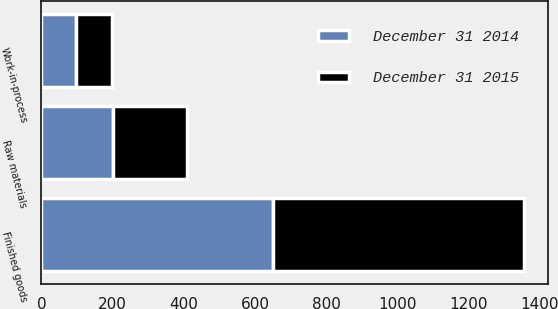Convert chart to OTSL. <chart><loc_0><loc_0><loc_500><loc_500><stacked_bar_chart><ecel><fcel>Finished goods<fcel>Work-in-process<fcel>Raw materials<nl><fcel>December 31 2015<fcel>706<fcel>102<fcel>208<nl><fcel>December 31 2014<fcel>649<fcel>97<fcel>200<nl></chart> 